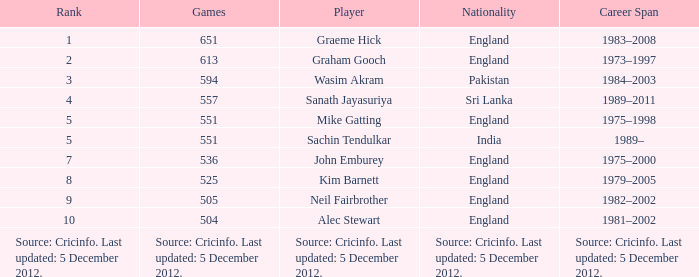What is wasim akram's standing? 3.0. 